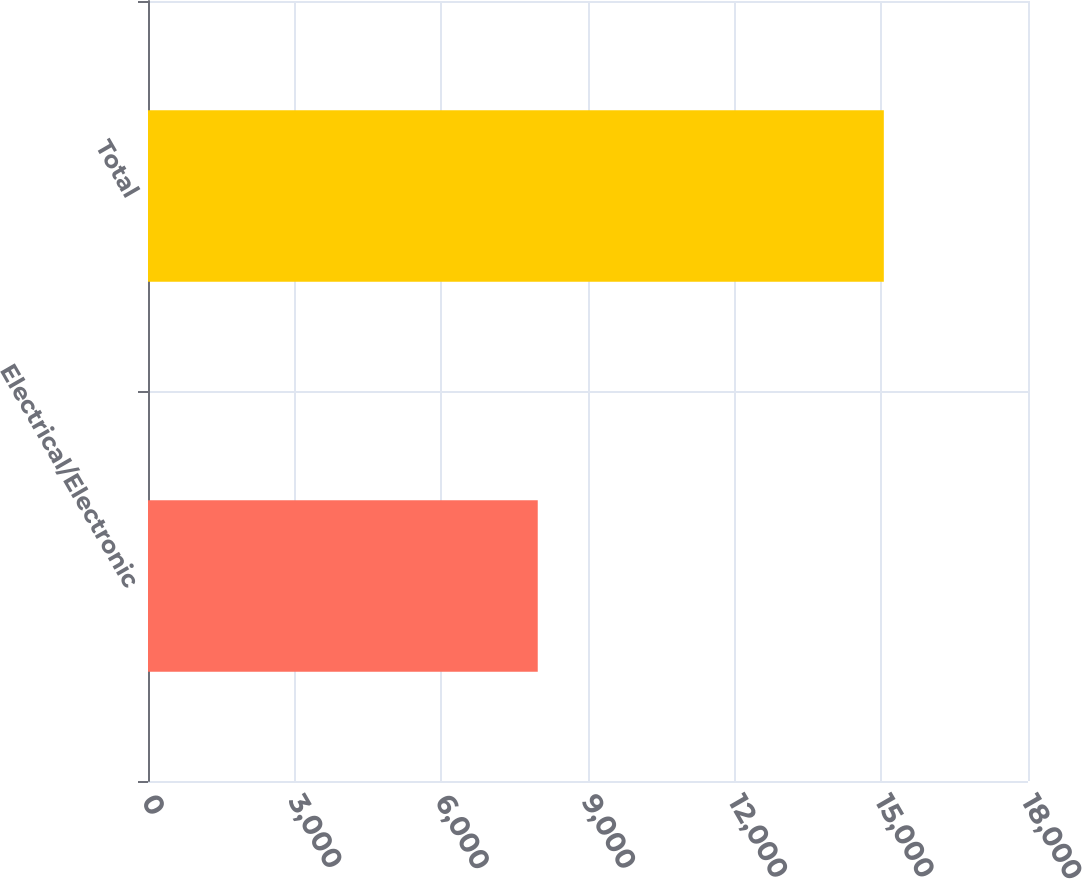Convert chart. <chart><loc_0><loc_0><loc_500><loc_500><bar_chart><fcel>Electrical/Electronic<fcel>Total<nl><fcel>7972<fcel>15051<nl></chart> 